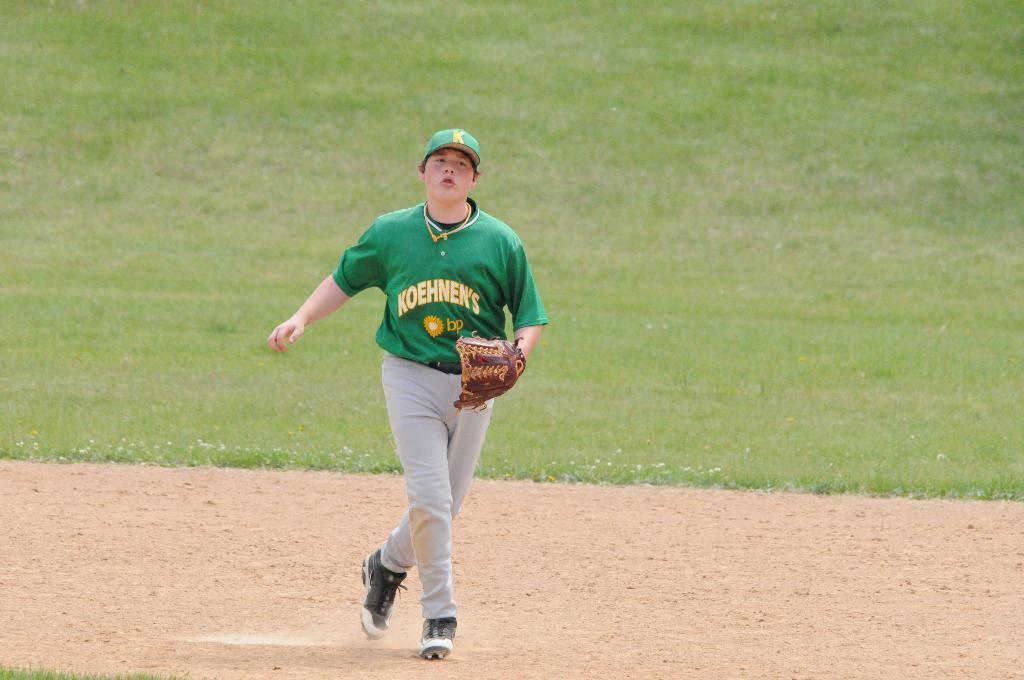<image>
Write a terse but informative summary of the picture. A baseball player has the team name Koehnen's on his jersey. 